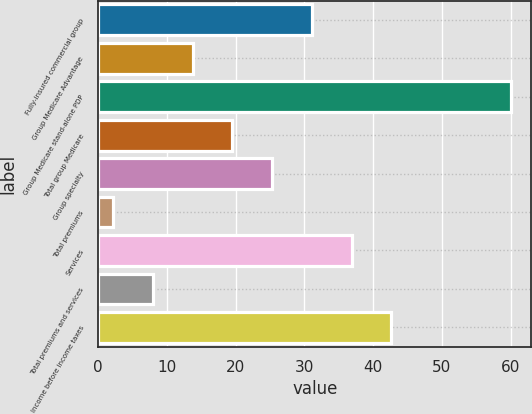Convert chart to OTSL. <chart><loc_0><loc_0><loc_500><loc_500><bar_chart><fcel>Fully-insured commercial group<fcel>Group Medicare Advantage<fcel>Group Medicare stand-alone PDP<fcel>Total group Medicare<fcel>Group specialty<fcel>Total premiums<fcel>Services<fcel>Total premiums and services<fcel>Income before income taxes<nl><fcel>31.1<fcel>13.76<fcel>60<fcel>19.54<fcel>25.32<fcel>2.2<fcel>36.88<fcel>7.98<fcel>42.66<nl></chart> 